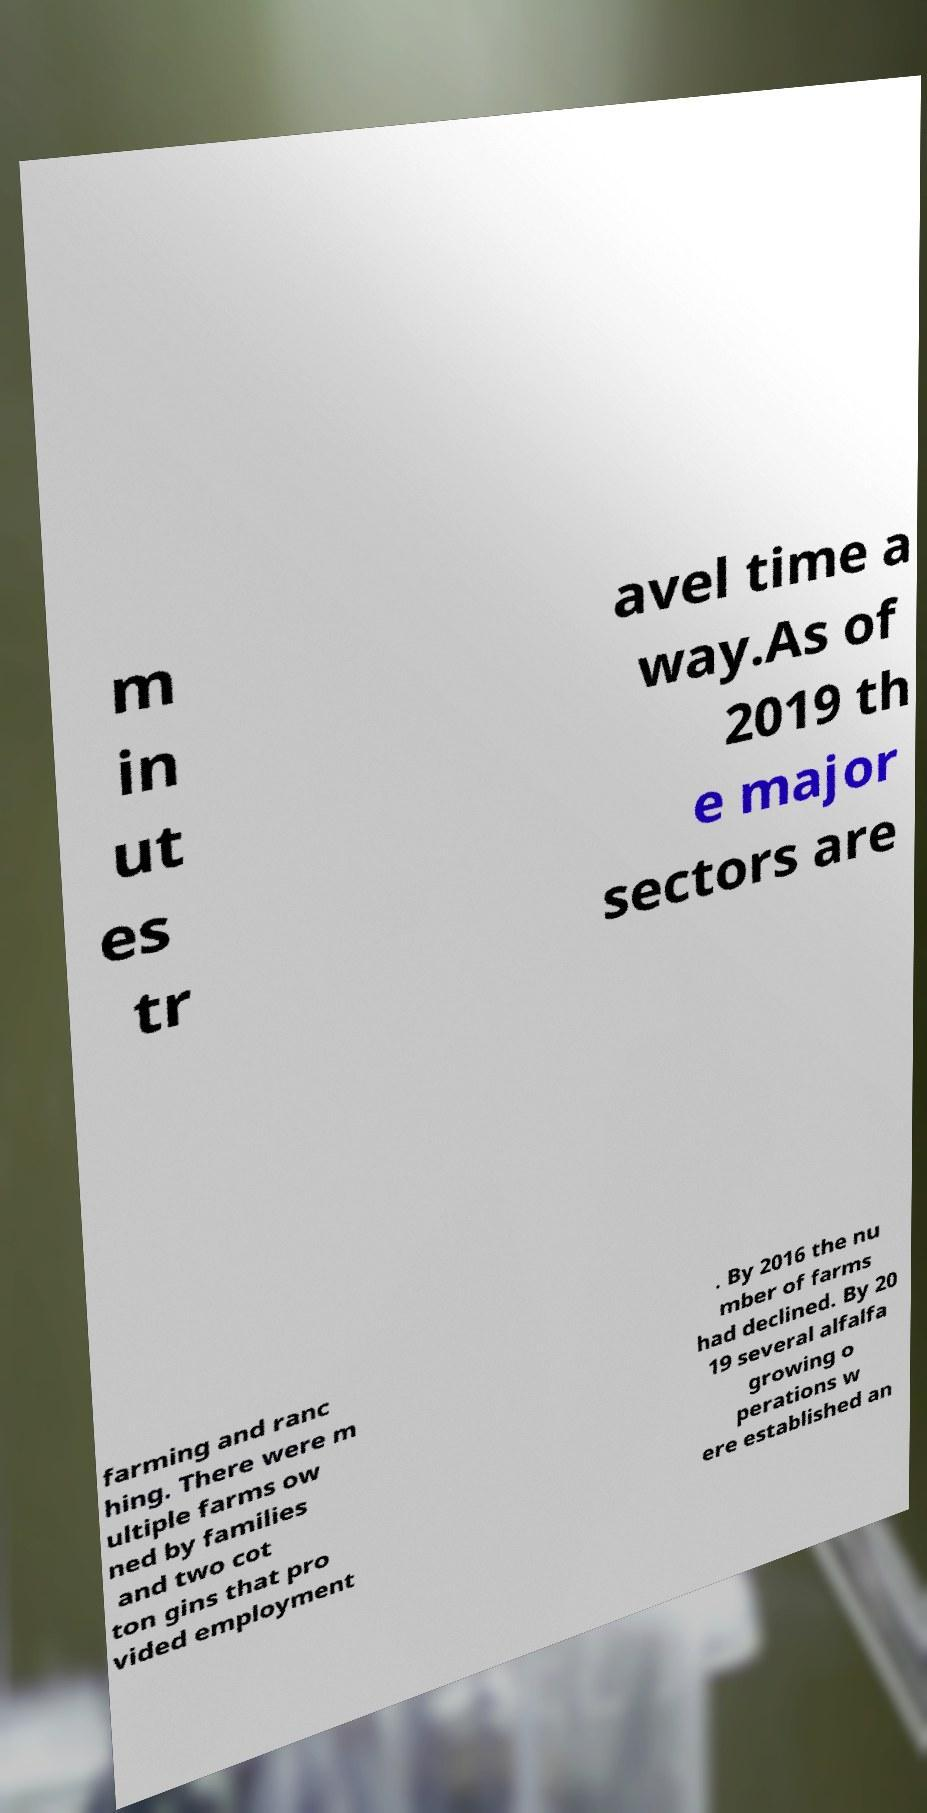Please identify and transcribe the text found in this image. m in ut es tr avel time a way.As of 2019 th e major sectors are farming and ranc hing. There were m ultiple farms ow ned by families and two cot ton gins that pro vided employment . By 2016 the nu mber of farms had declined. By 20 19 several alfalfa growing o perations w ere established an 